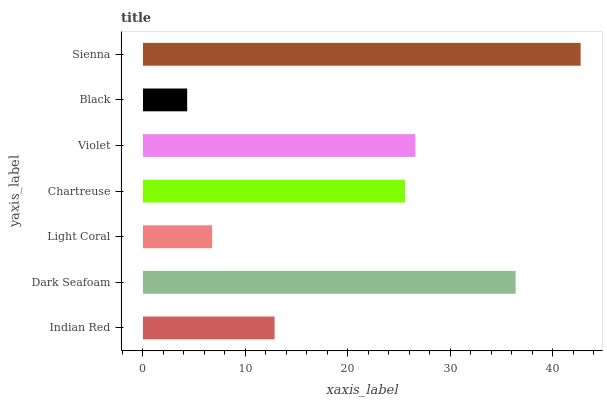Is Black the minimum?
Answer yes or no. Yes. Is Sienna the maximum?
Answer yes or no. Yes. Is Dark Seafoam the minimum?
Answer yes or no. No. Is Dark Seafoam the maximum?
Answer yes or no. No. Is Dark Seafoam greater than Indian Red?
Answer yes or no. Yes. Is Indian Red less than Dark Seafoam?
Answer yes or no. Yes. Is Indian Red greater than Dark Seafoam?
Answer yes or no. No. Is Dark Seafoam less than Indian Red?
Answer yes or no. No. Is Chartreuse the high median?
Answer yes or no. Yes. Is Chartreuse the low median?
Answer yes or no. Yes. Is Indian Red the high median?
Answer yes or no. No. Is Violet the low median?
Answer yes or no. No. 